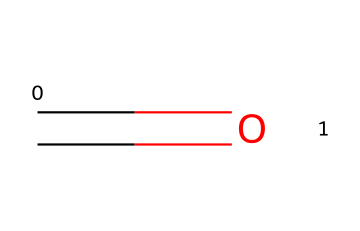What is the molecular formula of formaldehyde? The SMILES notation shows a carbon atom (C) double-bonded to an oxygen atom (O), indicating there are one carbon and one oxygen in the molecule. The implication is that the molecular formula is CH2O.
Answer: CH2O How many double bonds does formaldehyde contain? The SMILES representation shows one double bond between the carbon atom and the oxygen atom. This indicates that formaldehyde contains one double bond.
Answer: 1 What type of functional group does formaldehyde belong to? The presence of a carbonyl group (C=O) in the structure indicates that formaldehyde is classified as an aldehyde, which is characterized by a carbon atom bonded to a carbonyl group and a hydrogen atom.
Answer: aldehyde Is formaldehyde a saturated or unsaturated compound? Since formaldehyde contains a double bond, it is classified as an unsaturated compound. Saturated compounds have only single bonds, while unsaturated compounds contain double or triple bonds.
Answer: unsaturated What is the primary use of formaldehyde in morgues? Formaldehyde is primarily used as a preservative to prevent decay of biological tissues, maintaining their appearance and structure for examination or study.
Answer: preservative Which element in formaldehyde is responsible for its toxic properties? Oxygen is a key element as it participates in the formation of the carbonyl group, which contributes to formaldehyde's reactivity and toxicity. The structure also reveals that its presence can lead to harmful effects upon exposure.
Answer: oxygen 